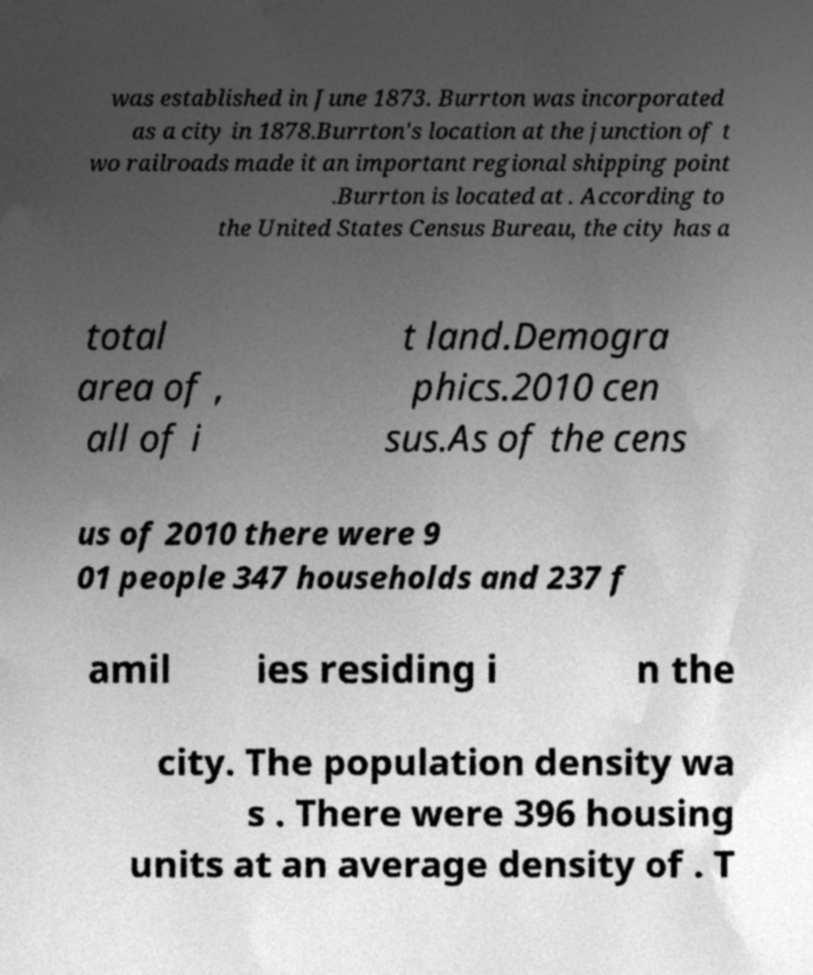Can you read and provide the text displayed in the image?This photo seems to have some interesting text. Can you extract and type it out for me? was established in June 1873. Burrton was incorporated as a city in 1878.Burrton's location at the junction of t wo railroads made it an important regional shipping point .Burrton is located at . According to the United States Census Bureau, the city has a total area of , all of i t land.Demogra phics.2010 cen sus.As of the cens us of 2010 there were 9 01 people 347 households and 237 f amil ies residing i n the city. The population density wa s . There were 396 housing units at an average density of . T 